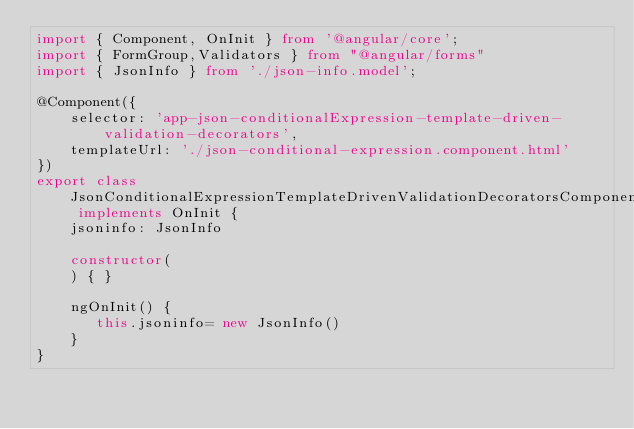<code> <loc_0><loc_0><loc_500><loc_500><_TypeScript_>import { Component, OnInit } from '@angular/core';
import { FormGroup,Validators } from "@angular/forms"
import { JsonInfo } from './json-info.model';

@Component({
    selector: 'app-json-conditionalExpression-template-driven-validation-decorators',
    templateUrl: './json-conditional-expression.component.html'
})
export class JsonConditionalExpressionTemplateDrivenValidationDecoratorsComponent implements OnInit {
    jsoninfo: JsonInfo
	
    constructor(
    ) { }

    ngOnInit() {
       this.jsoninfo= new JsonInfo()
    }
}
</code> 